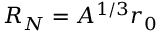<formula> <loc_0><loc_0><loc_500><loc_500>R _ { N } = A ^ { 1 / 3 } r _ { 0 }</formula> 